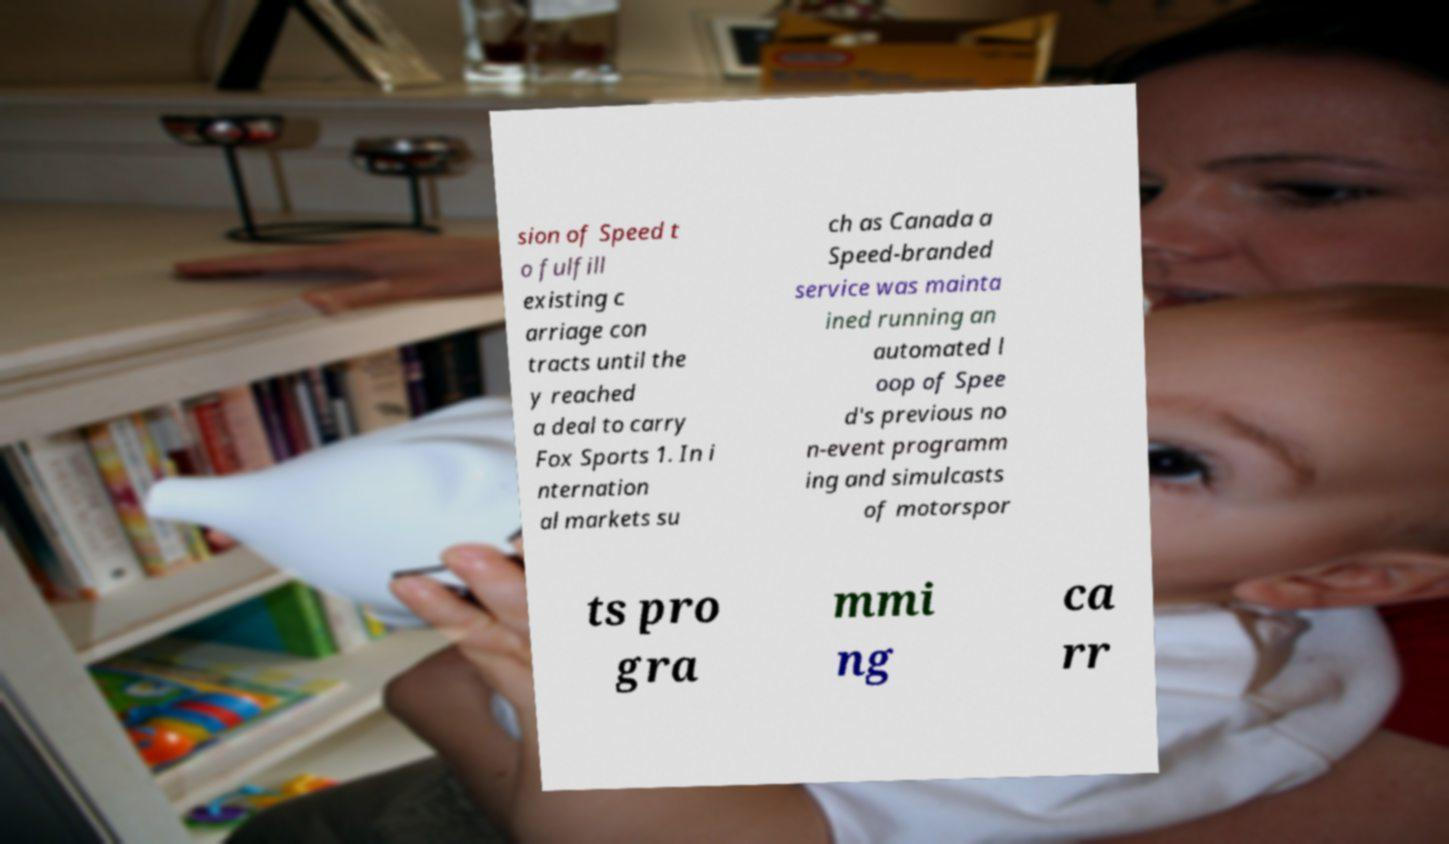Could you assist in decoding the text presented in this image and type it out clearly? sion of Speed t o fulfill existing c arriage con tracts until the y reached a deal to carry Fox Sports 1. In i nternation al markets su ch as Canada a Speed-branded service was mainta ined running an automated l oop of Spee d's previous no n-event programm ing and simulcasts of motorspor ts pro gra mmi ng ca rr 